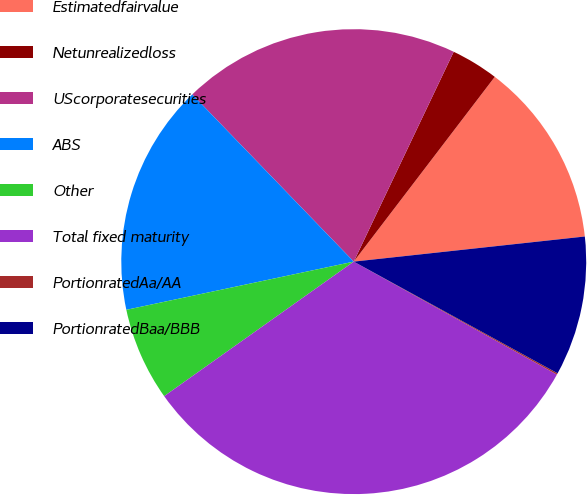Convert chart. <chart><loc_0><loc_0><loc_500><loc_500><pie_chart><fcel>Estimatedfairvalue<fcel>Netunrealizedloss<fcel>UScorporatesecurities<fcel>ABS<fcel>Other<fcel>Total fixed maturity<fcel>PortionratedAa/AA<fcel>PortionratedBaa/BBB<nl><fcel>12.9%<fcel>3.3%<fcel>19.3%<fcel>16.1%<fcel>6.5%<fcel>32.1%<fcel>0.1%<fcel>9.7%<nl></chart> 